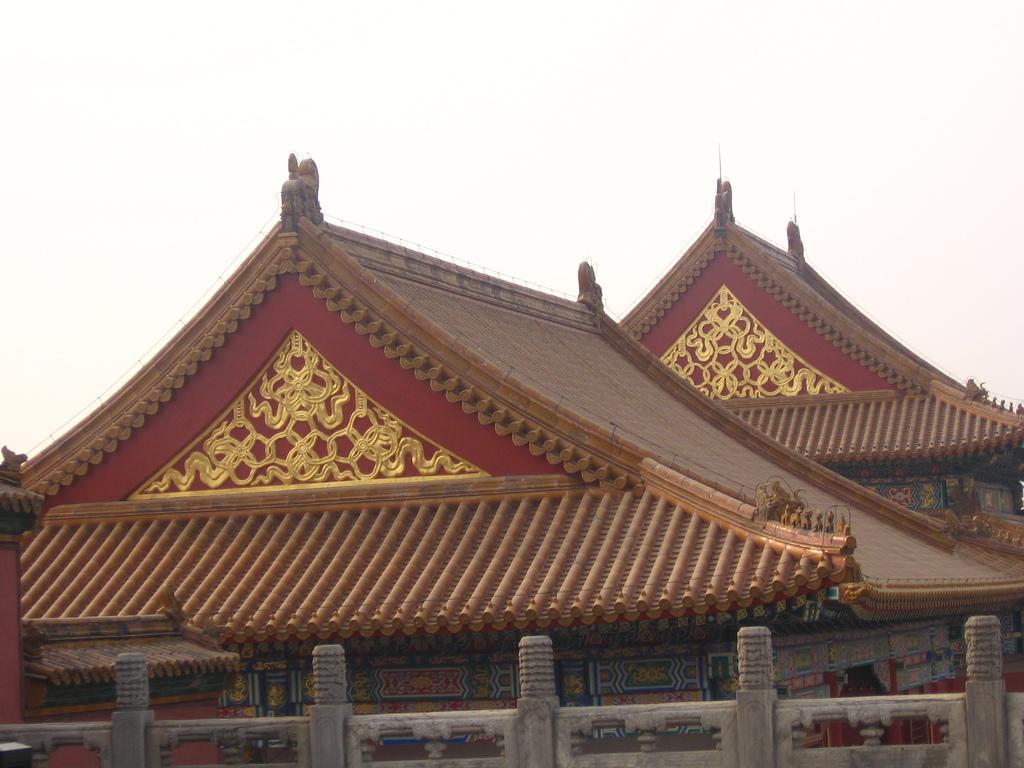Can you describe this image briefly? In this image I can see roofs of houses. In the background I can see the sky. 